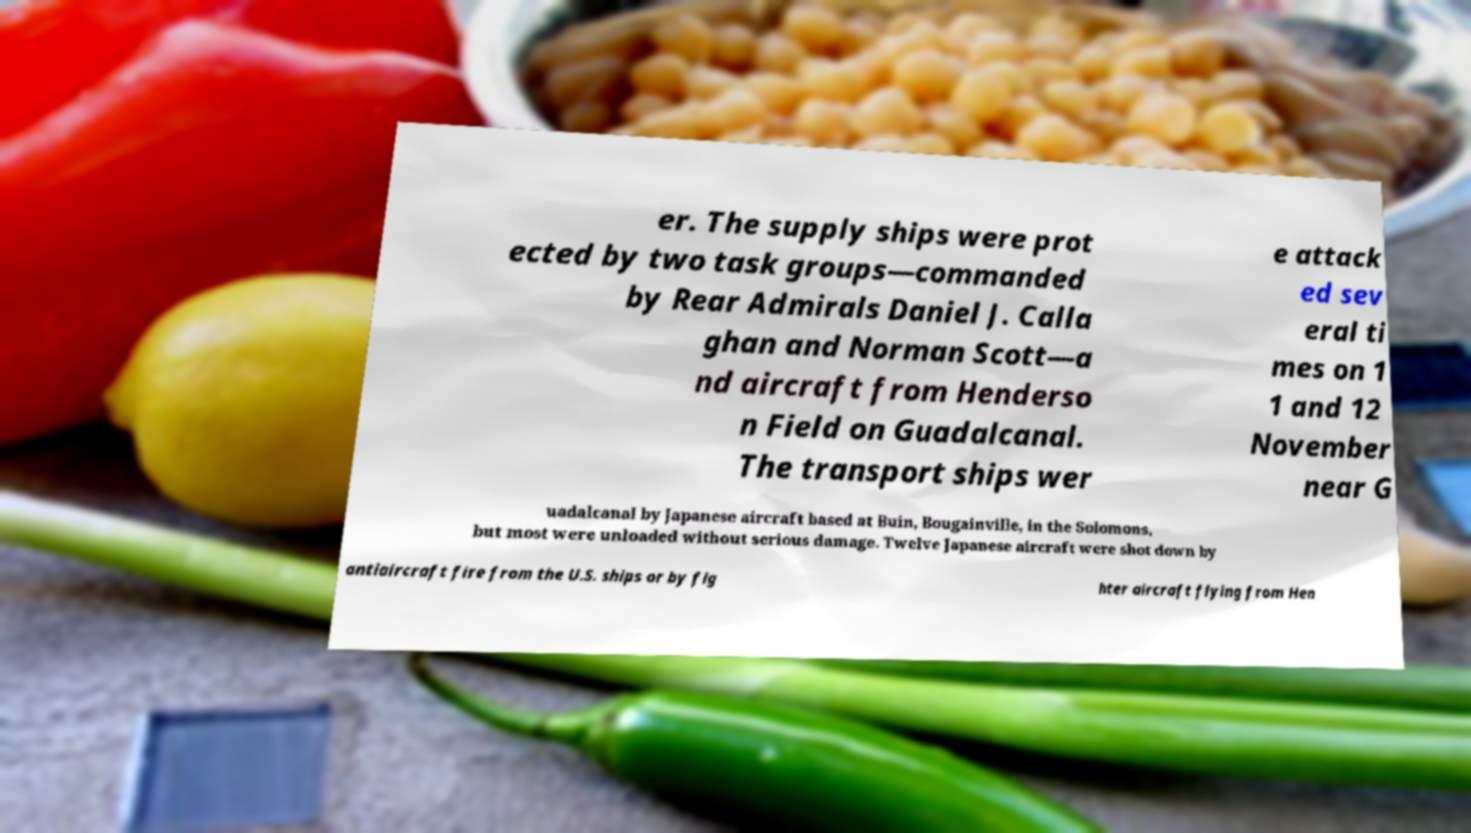I need the written content from this picture converted into text. Can you do that? er. The supply ships were prot ected by two task groups—commanded by Rear Admirals Daniel J. Calla ghan and Norman Scott—a nd aircraft from Henderso n Field on Guadalcanal. The transport ships wer e attack ed sev eral ti mes on 1 1 and 12 November near G uadalcanal by Japanese aircraft based at Buin, Bougainville, in the Solomons, but most were unloaded without serious damage. Twelve Japanese aircraft were shot down by antiaircraft fire from the U.S. ships or by fig hter aircraft flying from Hen 